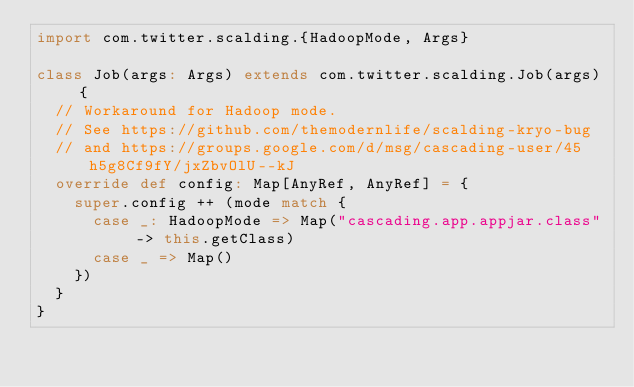<code> <loc_0><loc_0><loc_500><loc_500><_Scala_>import com.twitter.scalding.{HadoopMode, Args}

class Job(args: Args) extends com.twitter.scalding.Job(args) {
  // Workaround for Hadoop mode.
  // See https://github.com/themodernlife/scalding-kryo-bug
  // and https://groups.google.com/d/msg/cascading-user/45h5g8Cf9fY/jxZbvOlU--kJ
  override def config: Map[AnyRef, AnyRef] = {
    super.config ++ (mode match {
      case _: HadoopMode => Map("cascading.app.appjar.class" -> this.getClass)
      case _ => Map()
    })
  }
}
</code> 